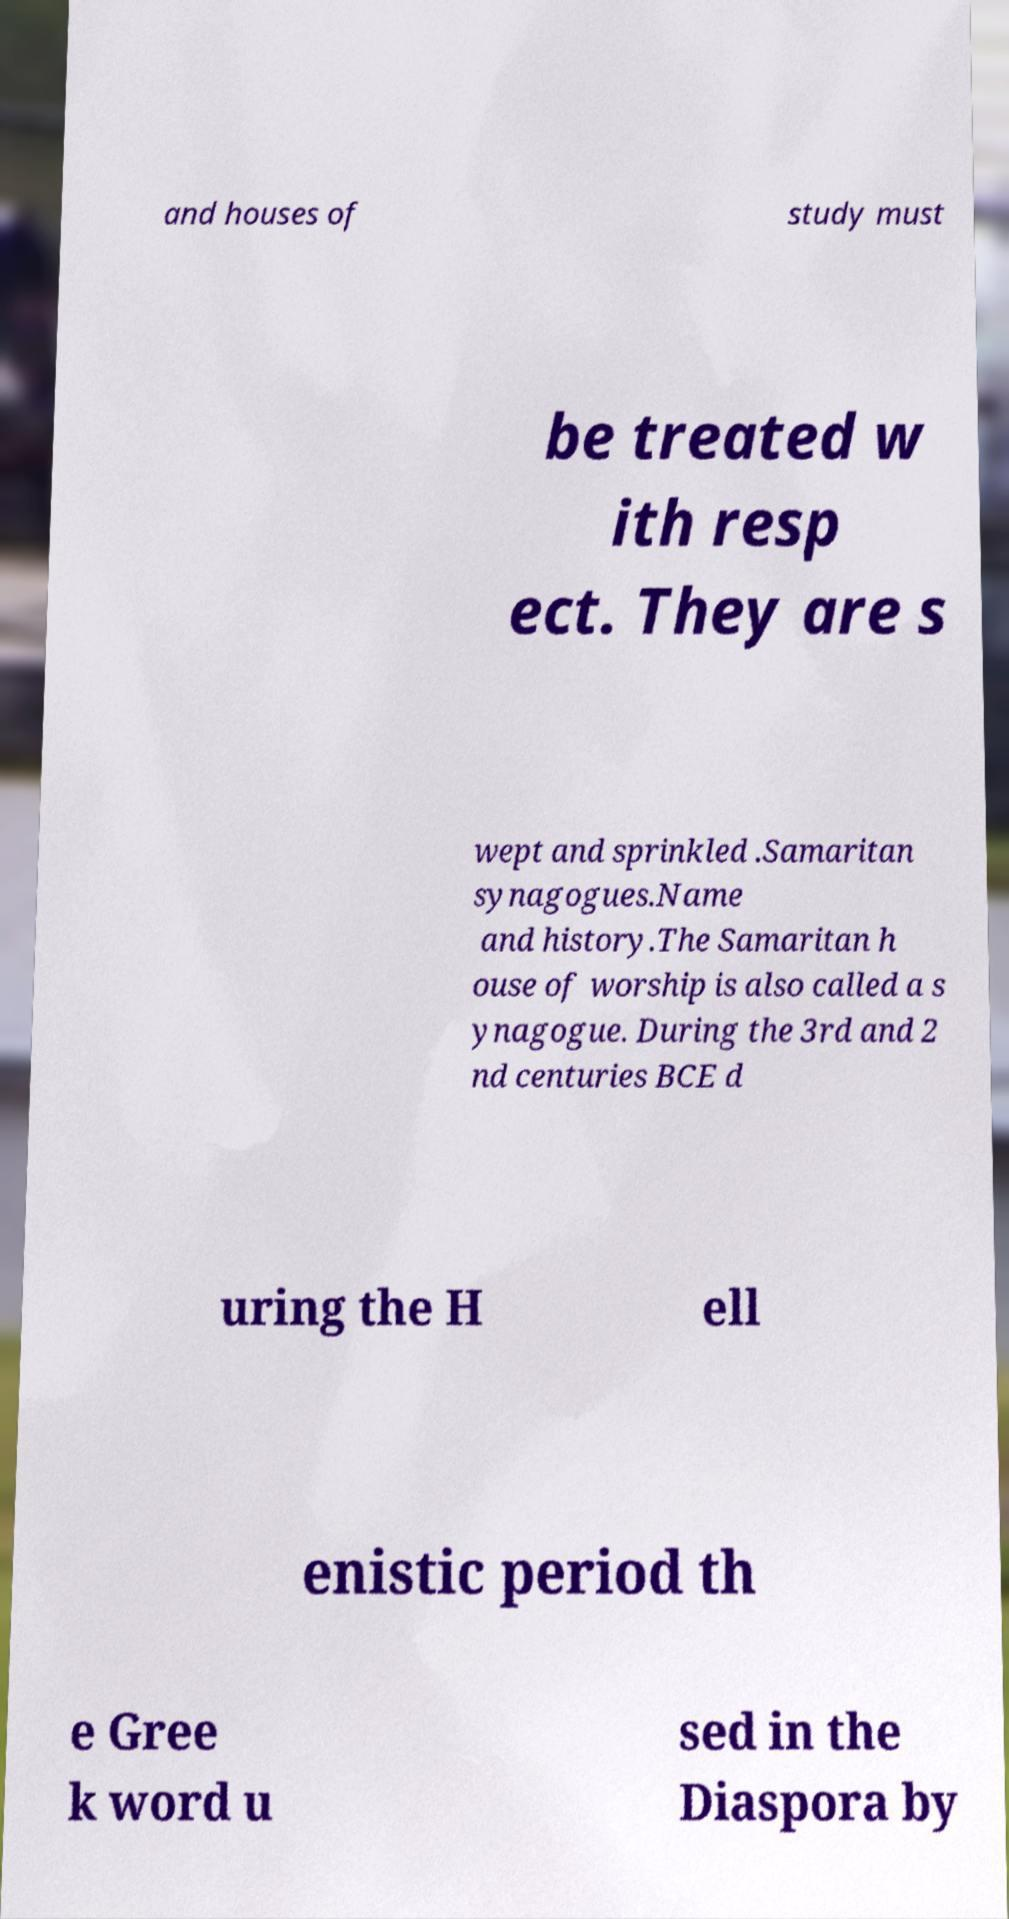Can you read and provide the text displayed in the image?This photo seems to have some interesting text. Can you extract and type it out for me? and houses of study must be treated w ith resp ect. They are s wept and sprinkled .Samaritan synagogues.Name and history.The Samaritan h ouse of worship is also called a s ynagogue. During the 3rd and 2 nd centuries BCE d uring the H ell enistic period th e Gree k word u sed in the Diaspora by 